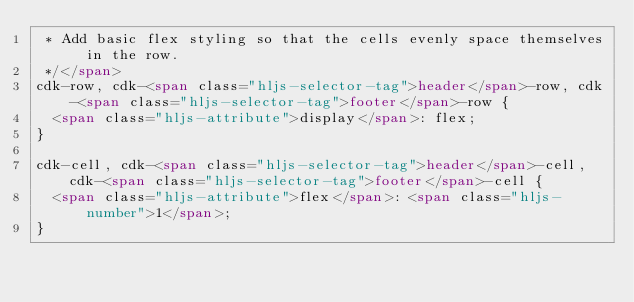Convert code to text. <code><loc_0><loc_0><loc_500><loc_500><_HTML_> * Add basic flex styling so that the cells evenly space themselves in the row.
 */</span>
cdk-row, cdk-<span class="hljs-selector-tag">header</span>-row, cdk-<span class="hljs-selector-tag">footer</span>-row {
  <span class="hljs-attribute">display</span>: flex;
}

cdk-cell, cdk-<span class="hljs-selector-tag">header</span>-cell, cdk-<span class="hljs-selector-tag">footer</span>-cell {
  <span class="hljs-attribute">flex</span>: <span class="hljs-number">1</span>;
}
</code> 